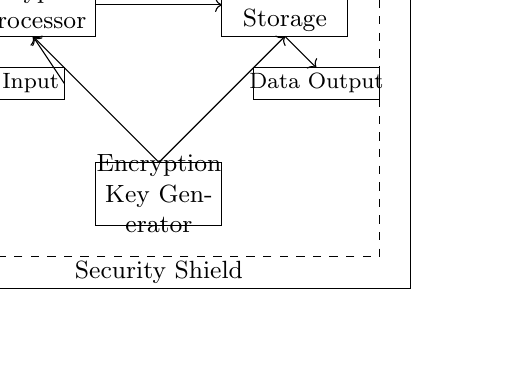What are the main components of the circuit? The main components are the Mobile Device, Encryption Processor, Secure Storage, Data Input, Data Output, and Encryption Key Generator. Each of these components is represented as a rectangle in the diagram.
Answer: Mobile Device, Encryption Processor, Secure Storage, Data Input, Data Output, Encryption Key Generator What is the purpose of the Encryption Processor? The Encryption Processor is responsible for encrypting the data input before it is sent to the secure storage. This is evident from the connection arrows entering and exiting this component.
Answer: Encrypting data What connects the Data Input to the Encryption Processor? The Data Input is connected to the Encryption Processor by a directional arrow, indicating a flow of data from the input to the encryption process.
Answer: An arrow How many rectangles represent security components? There are two rectangles representing security components: the Encryption Processor and the Secure Storage, both of which are crucial for protecting the data.
Answer: Two Where does the Data Output get its data from? The Data Output receives its data from the Secure Storage, as indicated by the arrow pointing from the Secure Storage rectangle to the Data Output rectangle.
Answer: Secure Storage What is the function of the Encryption Key Generator? The Encryption Key Generator produces the keys used for encryption, indicated by its connection to both the Encryption Processor and itself, showing it supplies necessary data for encryption.
Answer: To generate encryption keys What overall concept does the dashed rectangle represent in the circuit? The dashed rectangle labeled "Security Shield" encompasses the components, representing the protective measures taken to secure sensitive information within the entire system of the mobile device.
Answer: Security Shield 